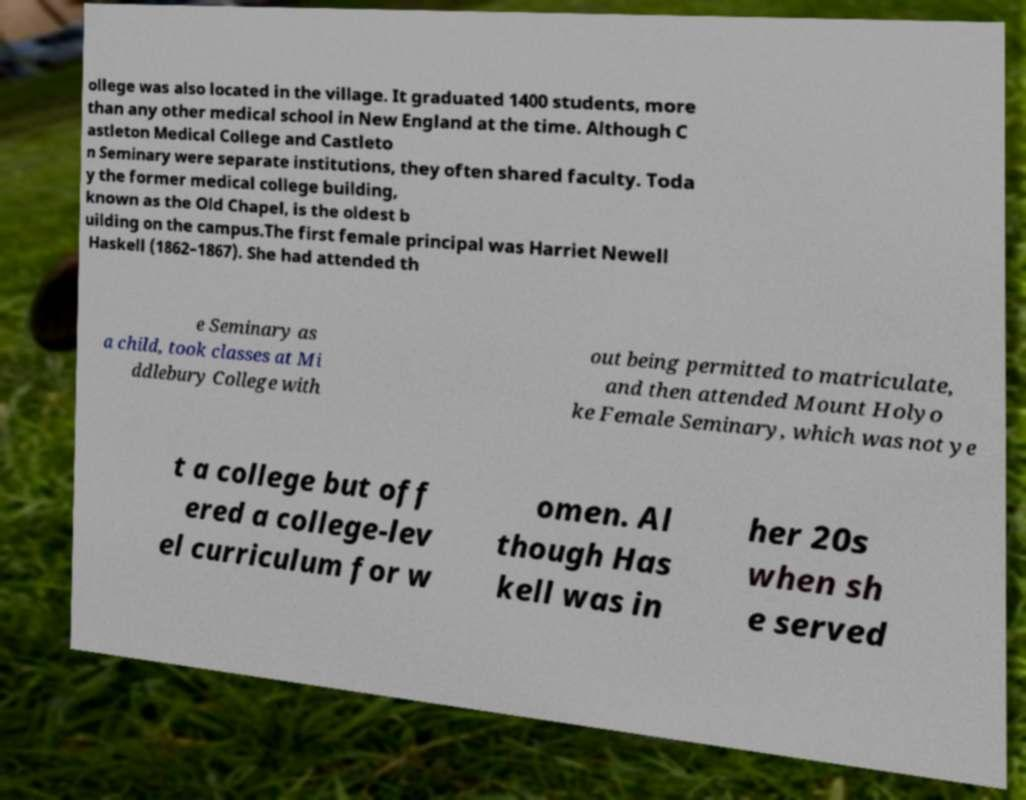Can you accurately transcribe the text from the provided image for me? ollege was also located in the village. It graduated 1400 students, more than any other medical school in New England at the time. Although C astleton Medical College and Castleto n Seminary were separate institutions, they often shared faculty. Toda y the former medical college building, known as the Old Chapel, is the oldest b uilding on the campus.The first female principal was Harriet Newell Haskell (1862–1867). She had attended th e Seminary as a child, took classes at Mi ddlebury College with out being permitted to matriculate, and then attended Mount Holyo ke Female Seminary, which was not ye t a college but off ered a college-lev el curriculum for w omen. Al though Has kell was in her 20s when sh e served 